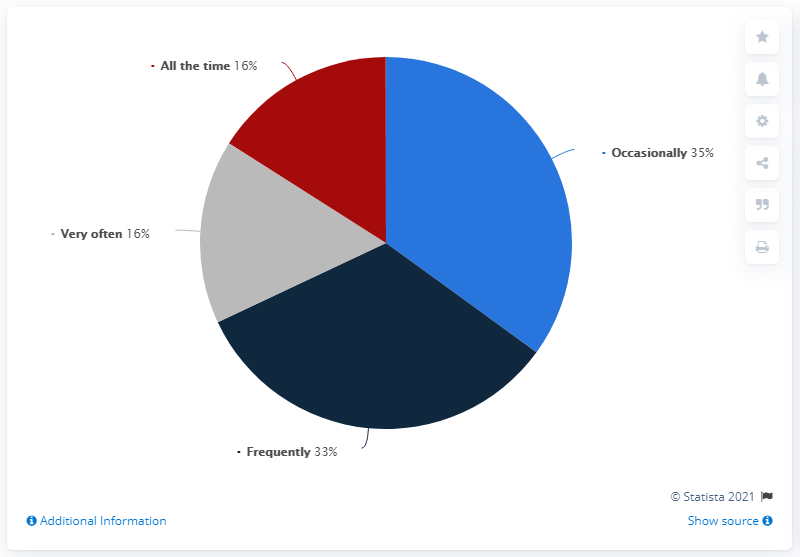List a handful of essential elements in this visual. The most frequent option is "occasionally. The top two options scored 68% each, indicating a strong preference for those options. 